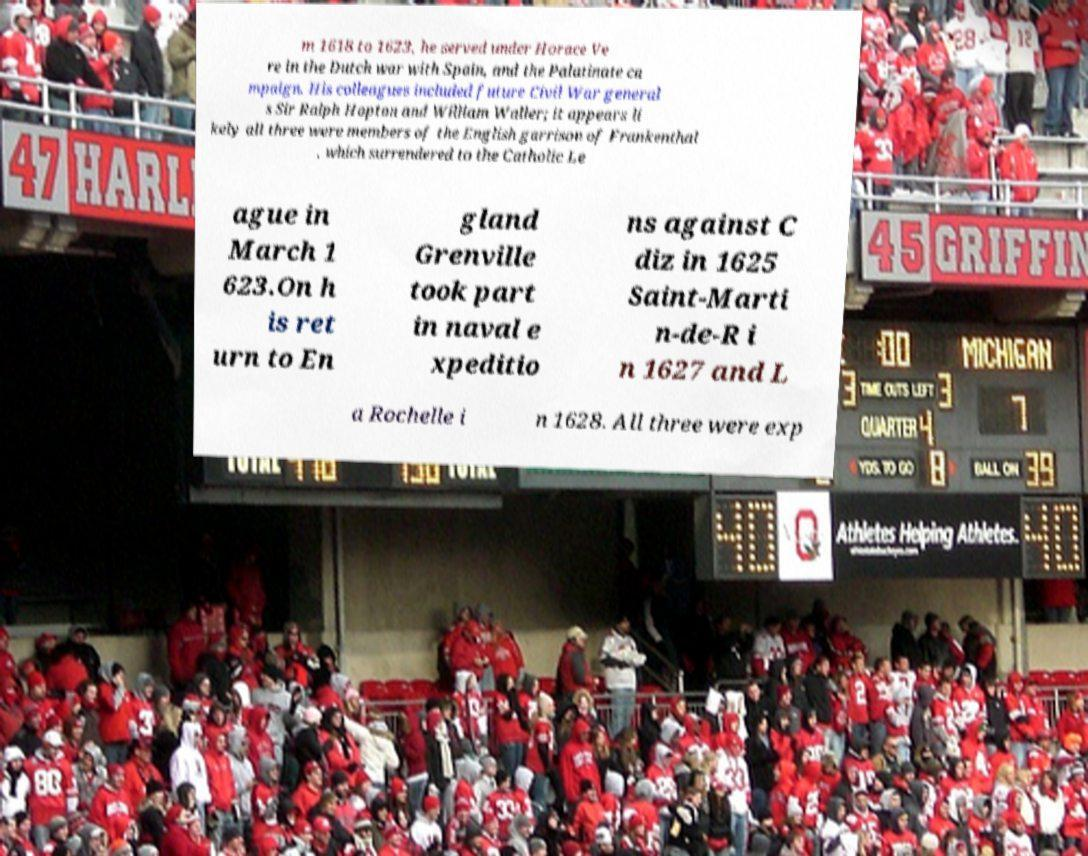Please identify and transcribe the text found in this image. m 1618 to 1623, he served under Horace Ve re in the Dutch war with Spain, and the Palatinate ca mpaign. His colleagues included future Civil War general s Sir Ralph Hopton and William Waller; it appears li kely all three were members of the English garrison of Frankenthal , which surrendered to the Catholic Le ague in March 1 623.On h is ret urn to En gland Grenville took part in naval e xpeditio ns against C diz in 1625 Saint-Marti n-de-R i n 1627 and L a Rochelle i n 1628. All three were exp 